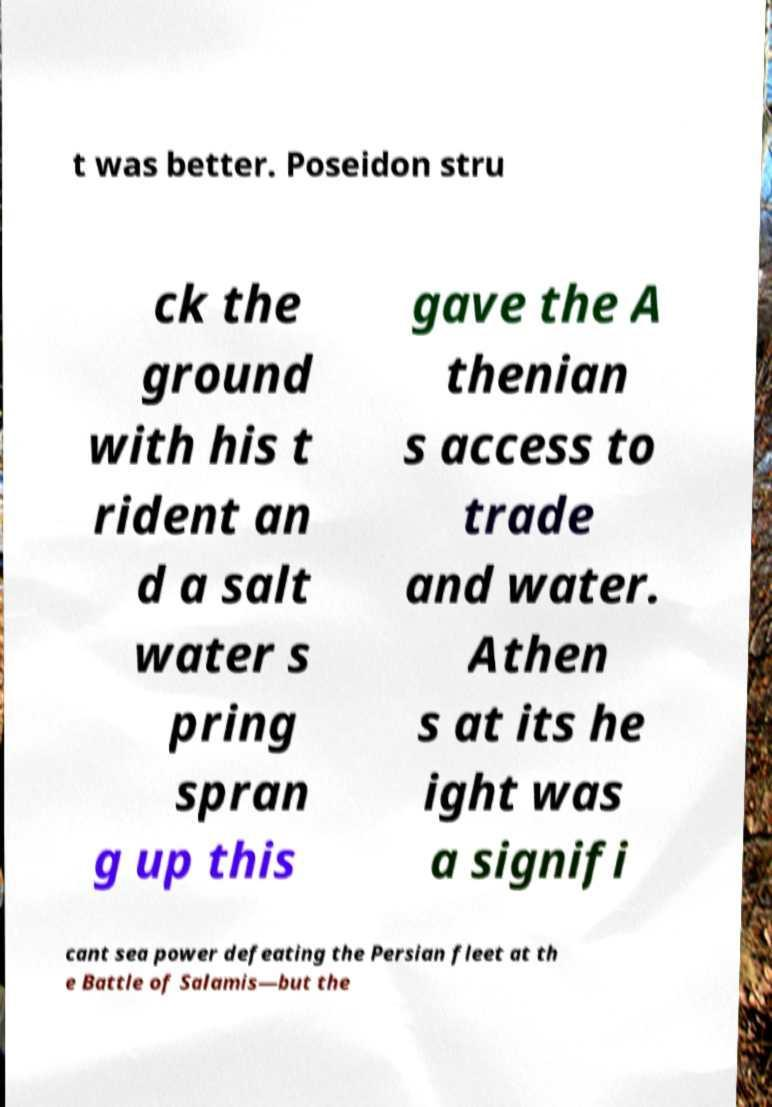Can you accurately transcribe the text from the provided image for me? t was better. Poseidon stru ck the ground with his t rident an d a salt water s pring spran g up this gave the A thenian s access to trade and water. Athen s at its he ight was a signifi cant sea power defeating the Persian fleet at th e Battle of Salamis—but the 